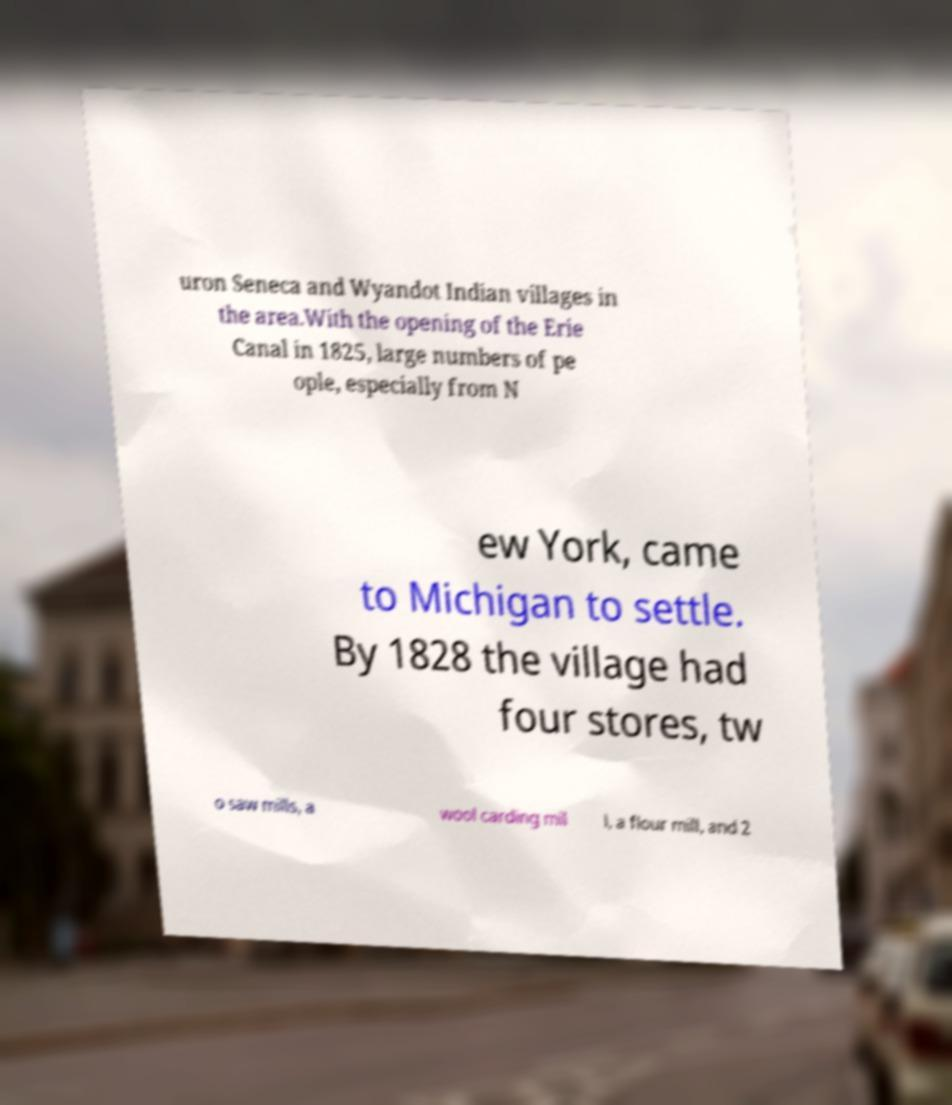Can you accurately transcribe the text from the provided image for me? uron Seneca and Wyandot Indian villages in the area.With the opening of the Erie Canal in 1825, large numbers of pe ople, especially from N ew York, came to Michigan to settle. By 1828 the village had four stores, tw o saw mills, a wool carding mil l, a flour mill, and 2 